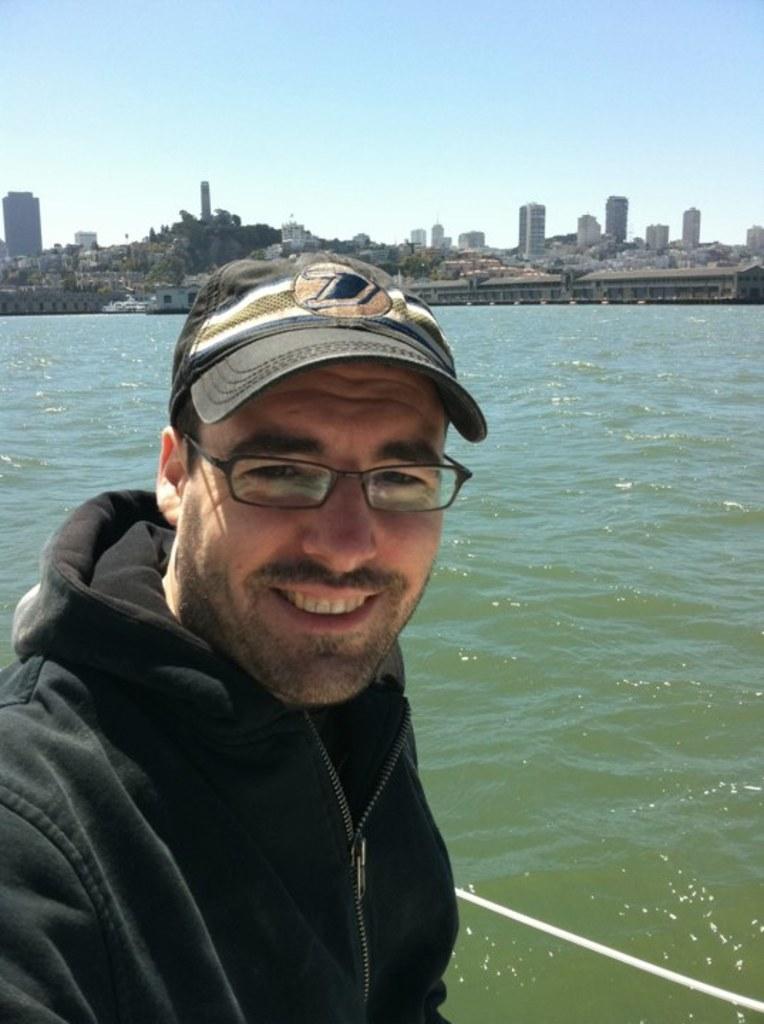Could you give a brief overview of what you see in this image? There is a person standing in the foreground area of the image, there are buildings, water and the sky in the background. 